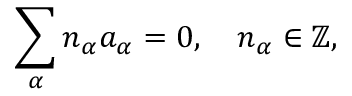Convert formula to latex. <formula><loc_0><loc_0><loc_500><loc_500>\sum _ { \alpha } n _ { \alpha } a _ { \alpha } = 0 , \quad n _ { \alpha } \in \mathbb { Z } ,</formula> 